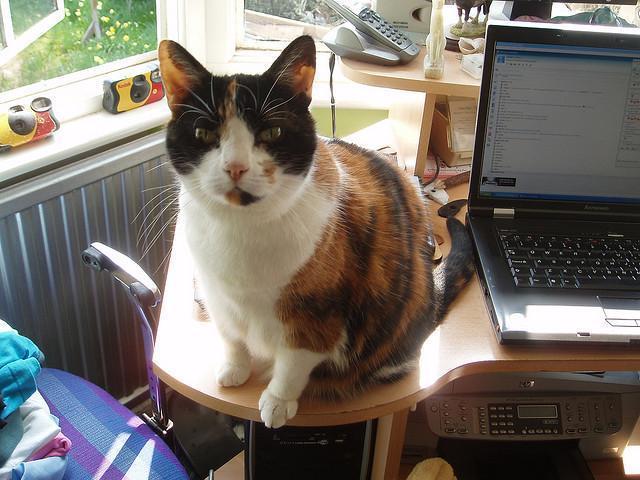How many chairs are in the photo?
Give a very brief answer. 2. 